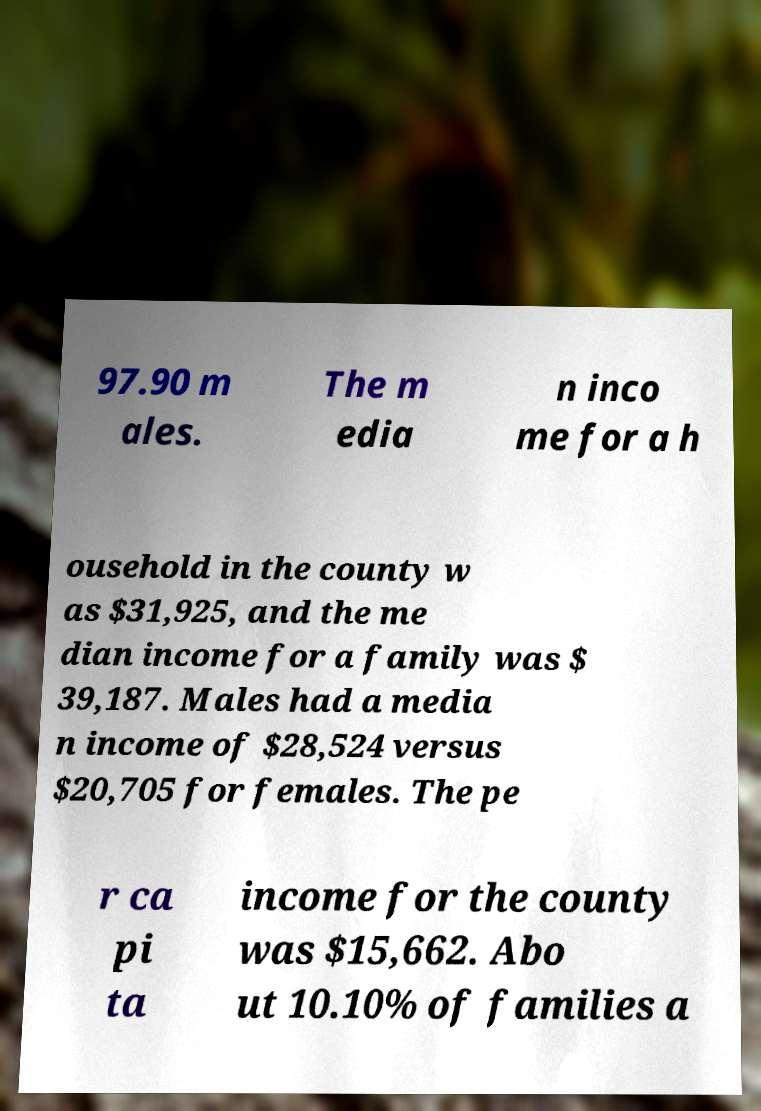Can you read and provide the text displayed in the image?This photo seems to have some interesting text. Can you extract and type it out for me? 97.90 m ales. The m edia n inco me for a h ousehold in the county w as $31,925, and the me dian income for a family was $ 39,187. Males had a media n income of $28,524 versus $20,705 for females. The pe r ca pi ta income for the county was $15,662. Abo ut 10.10% of families a 